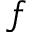Convert formula to latex. <formula><loc_0><loc_0><loc_500><loc_500>f</formula> 